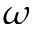Convert formula to latex. <formula><loc_0><loc_0><loc_500><loc_500>\omega</formula> 